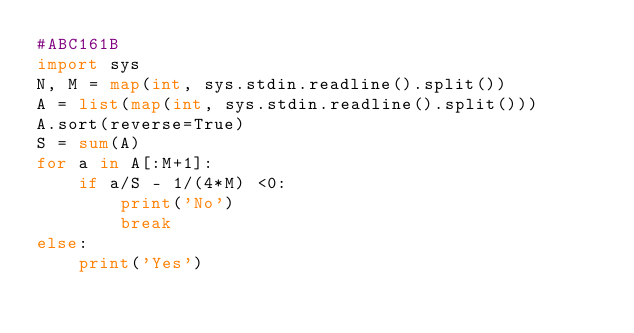Convert code to text. <code><loc_0><loc_0><loc_500><loc_500><_Python_>#ABC161B
import sys
N, M = map(int, sys.stdin.readline().split())
A = list(map(int, sys.stdin.readline().split()))
A.sort(reverse=True)
S = sum(A)
for a in A[:M+1]:
    if a/S - 1/(4*M) <0:
        print('No')
        break
else:
    print('Yes')</code> 